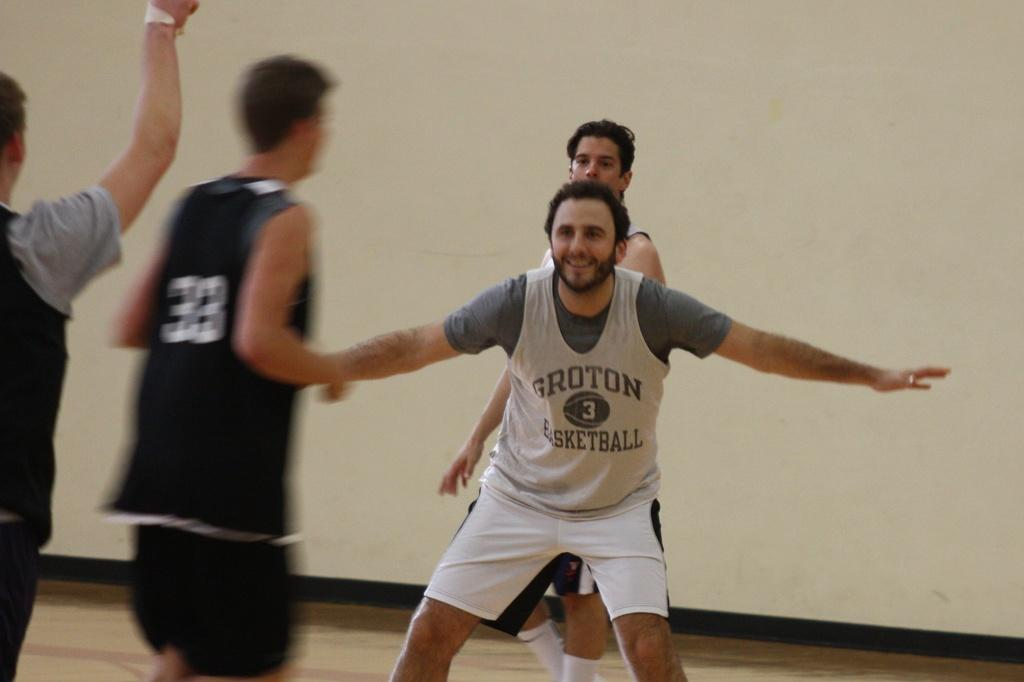Provide a one-sentence caption for the provided image. Groton basketball players playing on the basketball court. 